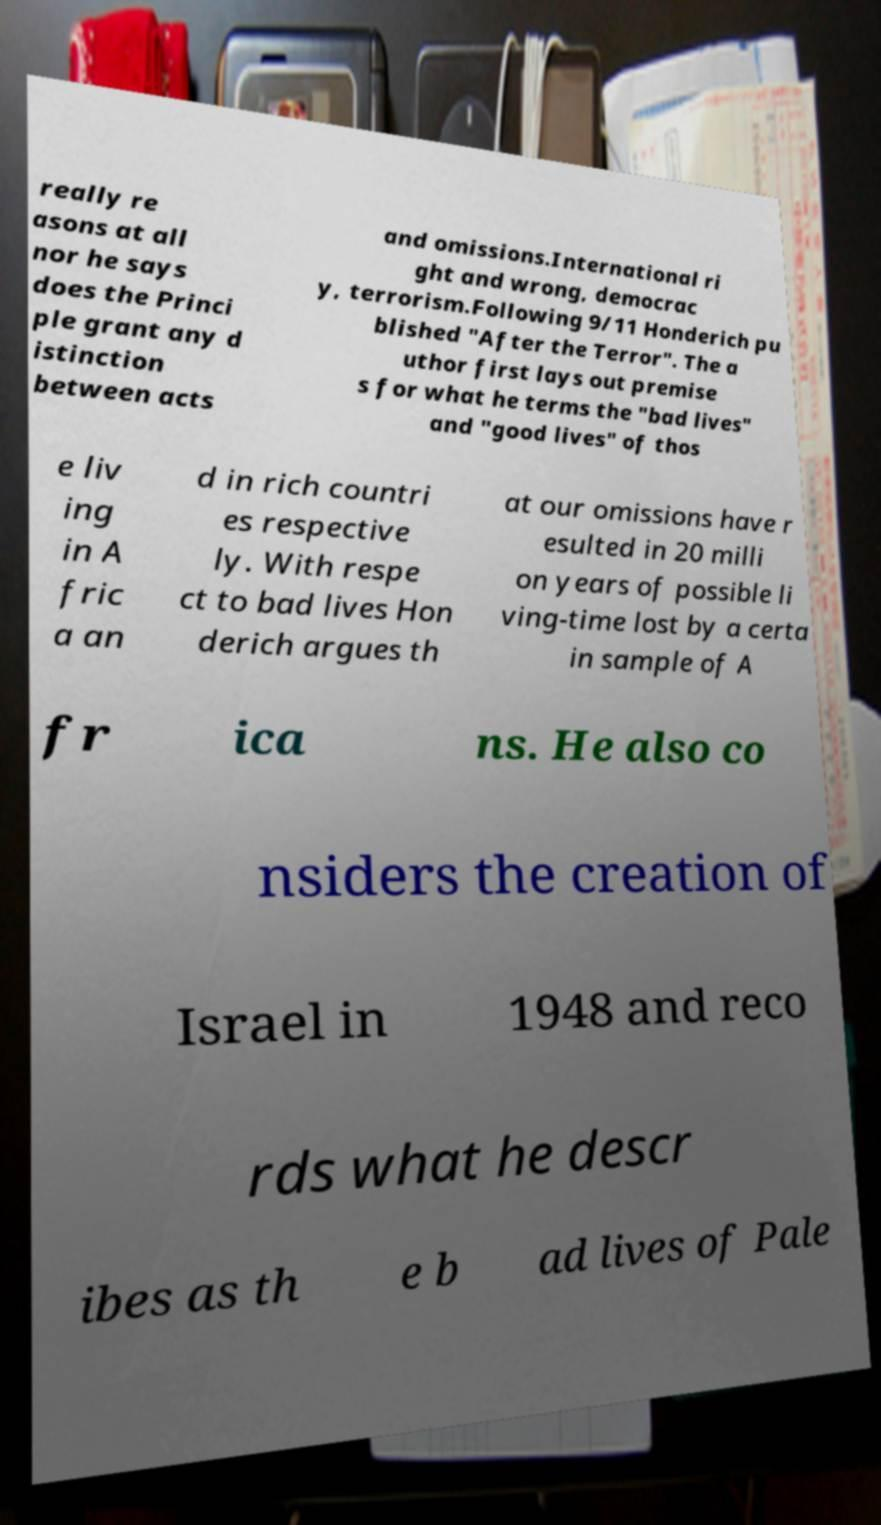Please identify and transcribe the text found in this image. really re asons at all nor he says does the Princi ple grant any d istinction between acts and omissions.International ri ght and wrong, democrac y, terrorism.Following 9/11 Honderich pu blished "After the Terror". The a uthor first lays out premise s for what he terms the "bad lives" and "good lives" of thos e liv ing in A fric a an d in rich countri es respective ly. With respe ct to bad lives Hon derich argues th at our omissions have r esulted in 20 milli on years of possible li ving-time lost by a certa in sample of A fr ica ns. He also co nsiders the creation of Israel in 1948 and reco rds what he descr ibes as th e b ad lives of Pale 